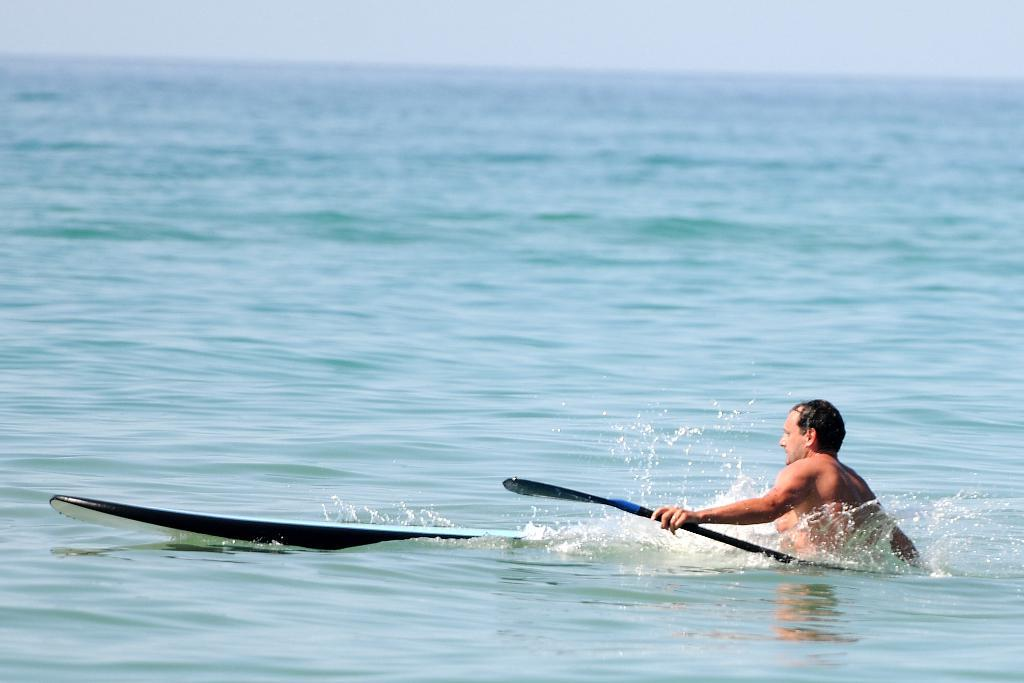Who is present in the image? There is a person in the image. What is the person holding in the image? The person is holding a paddle. Where is the person located in the image? The person is in the water. What else can be seen in the water in the image? There is a surfboard in the water. What is visible in the background of the image? The sky is visible in the background of the image. What type of gate can be seen in the image? There is no gate present in the image; it features a person in the water with a paddle and a surfboard. 